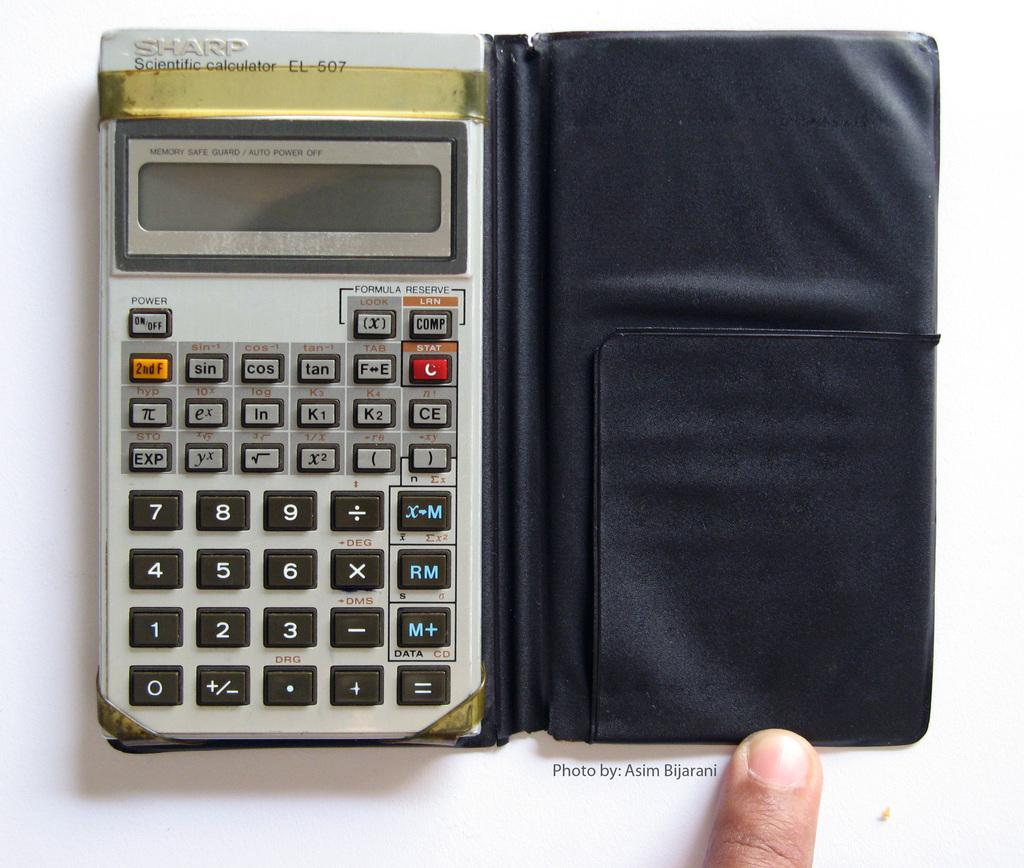<image>
Offer a succinct explanation of the picture presented. A Sharp Scientific Calculator is in a black holder, 